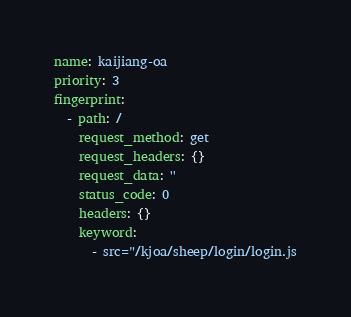<code> <loc_0><loc_0><loc_500><loc_500><_YAML_>name: kaijiang-oa
priority: 3
fingerprint:
  - path: /
    request_method: get
    request_headers: {}
    request_data: ''
    status_code: 0
    headers: {}
    keyword:
      - src="/kjoa/sheep/login/login.js
</code> 